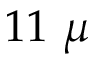Convert formula to latex. <formula><loc_0><loc_0><loc_500><loc_500>1 1 \ \mu</formula> 